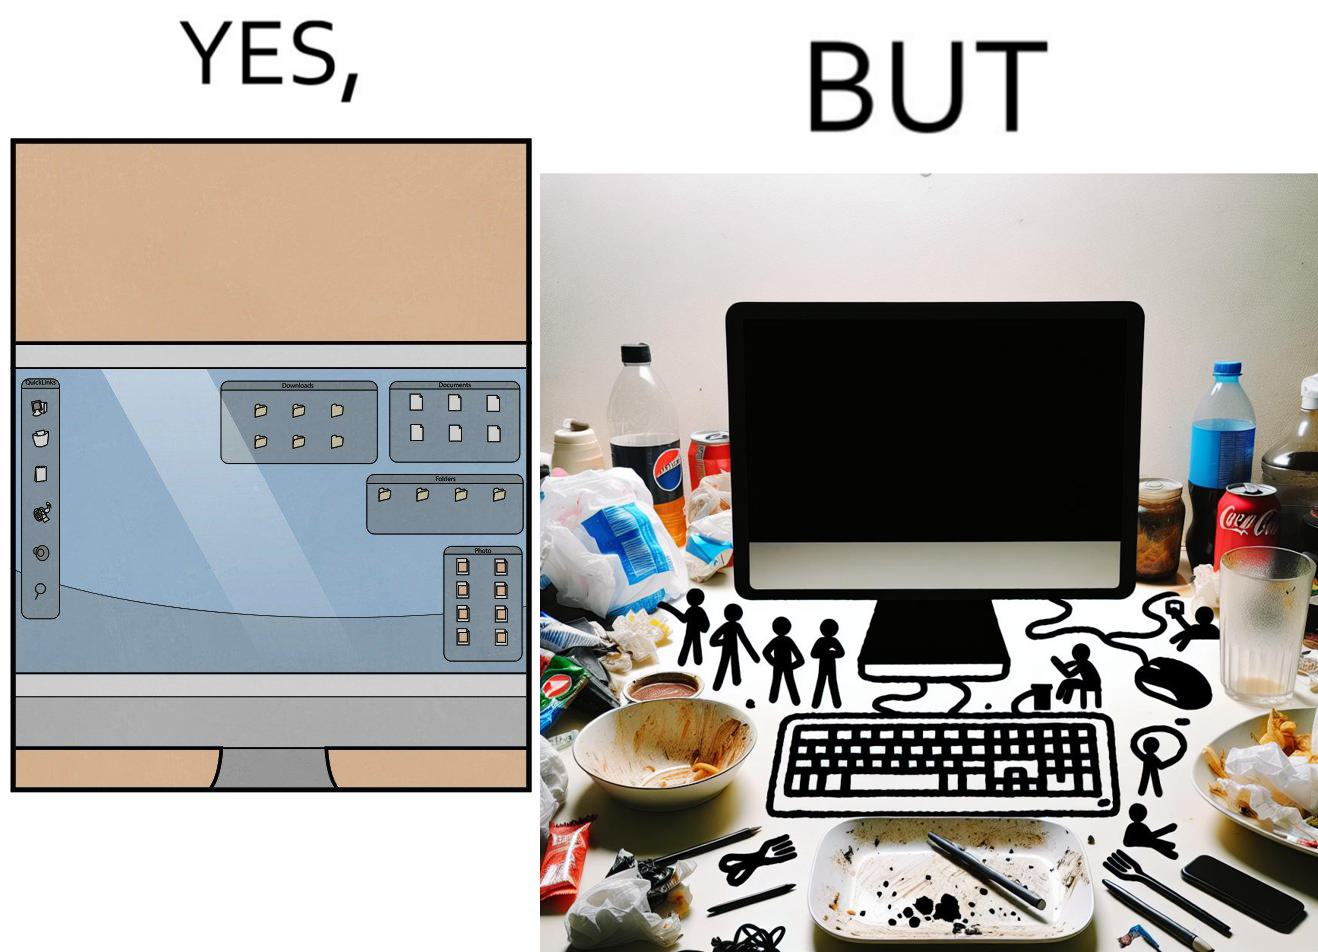Describe the content of this image. The image is ironical, as the folder icons on the desktop screen are very neatly arranged, while the person using the computer has littered the table with used food packets, dirty plates, and wrappers. 